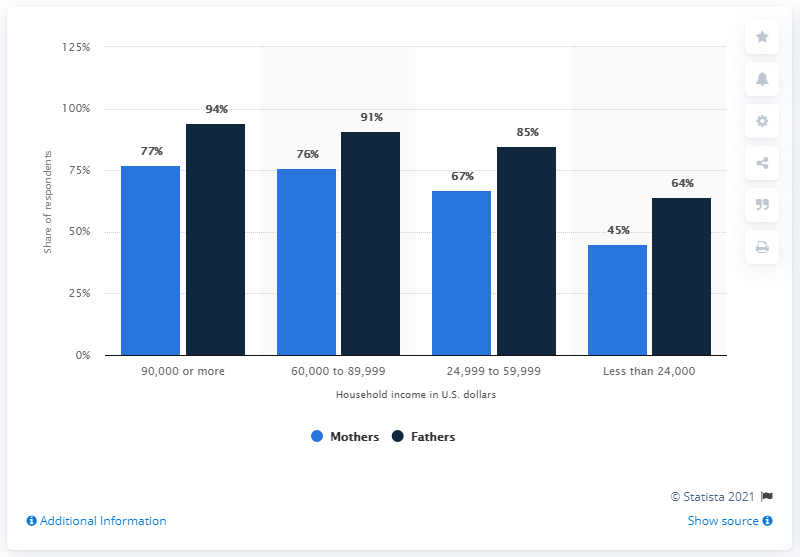Mention a couple of crucial points in this snapshot. The most popular sector for fathers is one that earns 90,000 or more. According to the data, the sector with the largest gap between mothers and fathers has less than 24,000. 